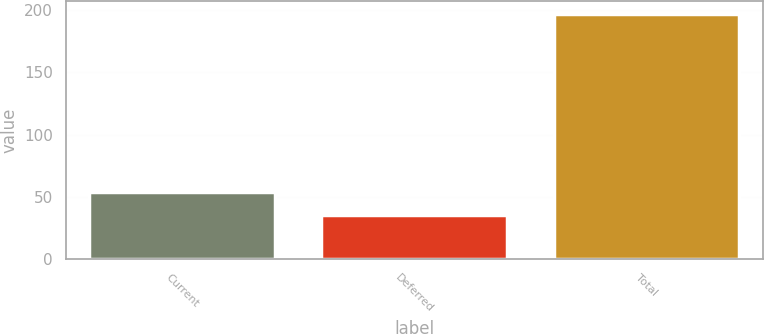Convert chart. <chart><loc_0><loc_0><loc_500><loc_500><bar_chart><fcel>Current<fcel>Deferred<fcel>Total<nl><fcel>54.3<fcel>35.7<fcel>196.9<nl></chart> 